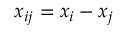Convert formula to latex. <formula><loc_0><loc_0><loc_500><loc_500>x _ { i j } = x _ { i } - x _ { j }</formula> 